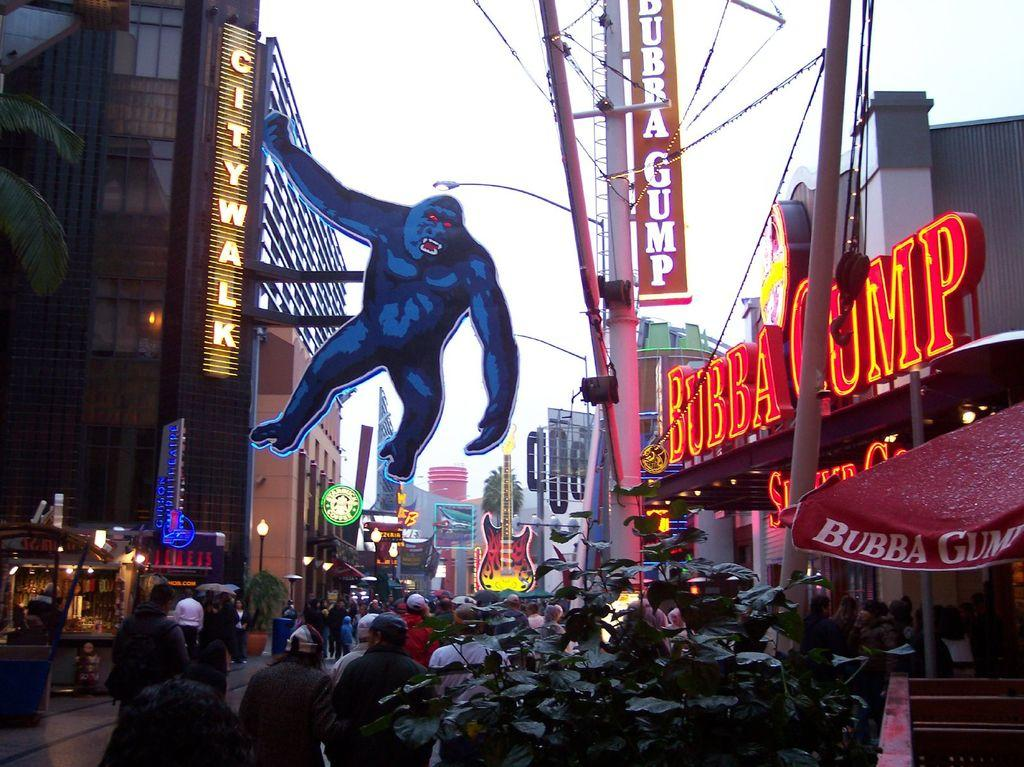What is the main setting of the image? The image depicts a street. What type of animal can be seen in the scene? There is an image of a gorilla in the scene. What is located on the right side of the image? There are names with lights on the right side. What is happening at the bottom of the image? People are walking at the bottom of the image. How many cakes are being divided among the people walking at the bottom of the image? There are no cakes present in the image, and therefore no division of cakes is taking place. 